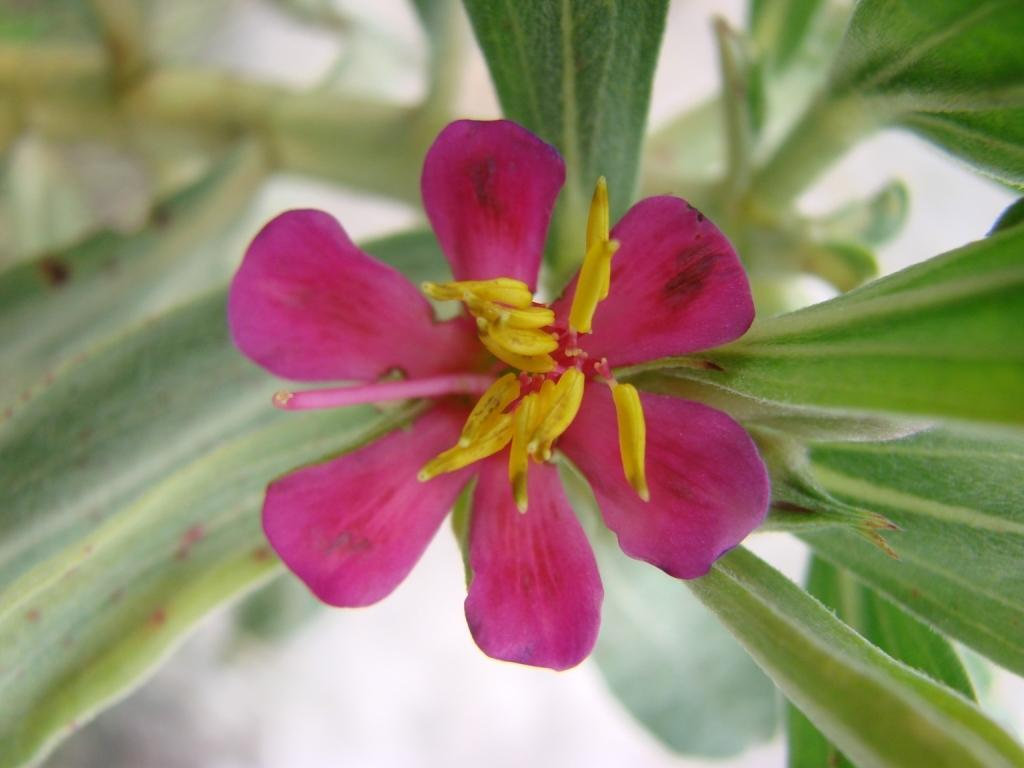What is the main subject of the image? There is a flower in the center of the image. What can be seen in the background of the image? There are leaves in the background of the image. How many slaves are depicted in the image? There are no slaves present in the image; it features a flower and leaves. What type of jar is visible in the image? There is no jar present in the image. 